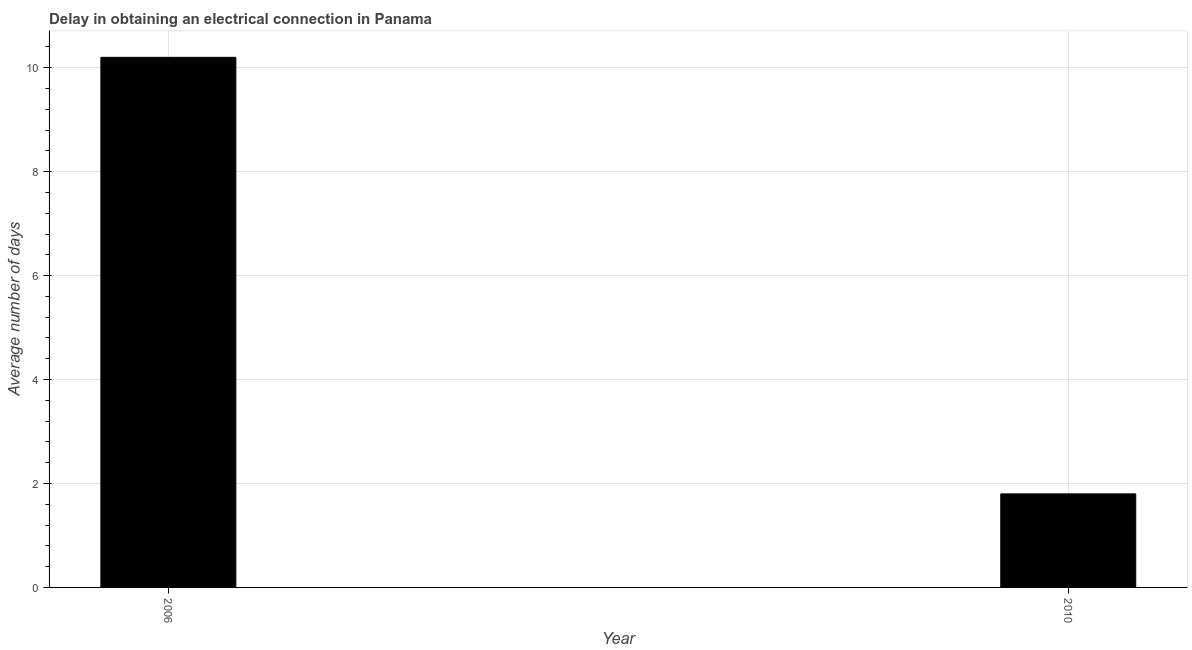Does the graph contain any zero values?
Offer a terse response. No. Does the graph contain grids?
Your answer should be compact. Yes. What is the title of the graph?
Give a very brief answer. Delay in obtaining an electrical connection in Panama. What is the label or title of the X-axis?
Your answer should be very brief. Year. What is the label or title of the Y-axis?
Your answer should be compact. Average number of days. Across all years, what is the maximum dalay in electrical connection?
Give a very brief answer. 10.2. In which year was the dalay in electrical connection maximum?
Keep it short and to the point. 2006. In which year was the dalay in electrical connection minimum?
Make the answer very short. 2010. What is the sum of the dalay in electrical connection?
Ensure brevity in your answer.  12. What is the ratio of the dalay in electrical connection in 2006 to that in 2010?
Provide a succinct answer. 5.67. In how many years, is the dalay in electrical connection greater than the average dalay in electrical connection taken over all years?
Your response must be concise. 1. How many bars are there?
Offer a very short reply. 2. What is the difference between two consecutive major ticks on the Y-axis?
Your answer should be compact. 2. Are the values on the major ticks of Y-axis written in scientific E-notation?
Make the answer very short. No. What is the difference between the Average number of days in 2006 and 2010?
Ensure brevity in your answer.  8.4. What is the ratio of the Average number of days in 2006 to that in 2010?
Your answer should be very brief. 5.67. 